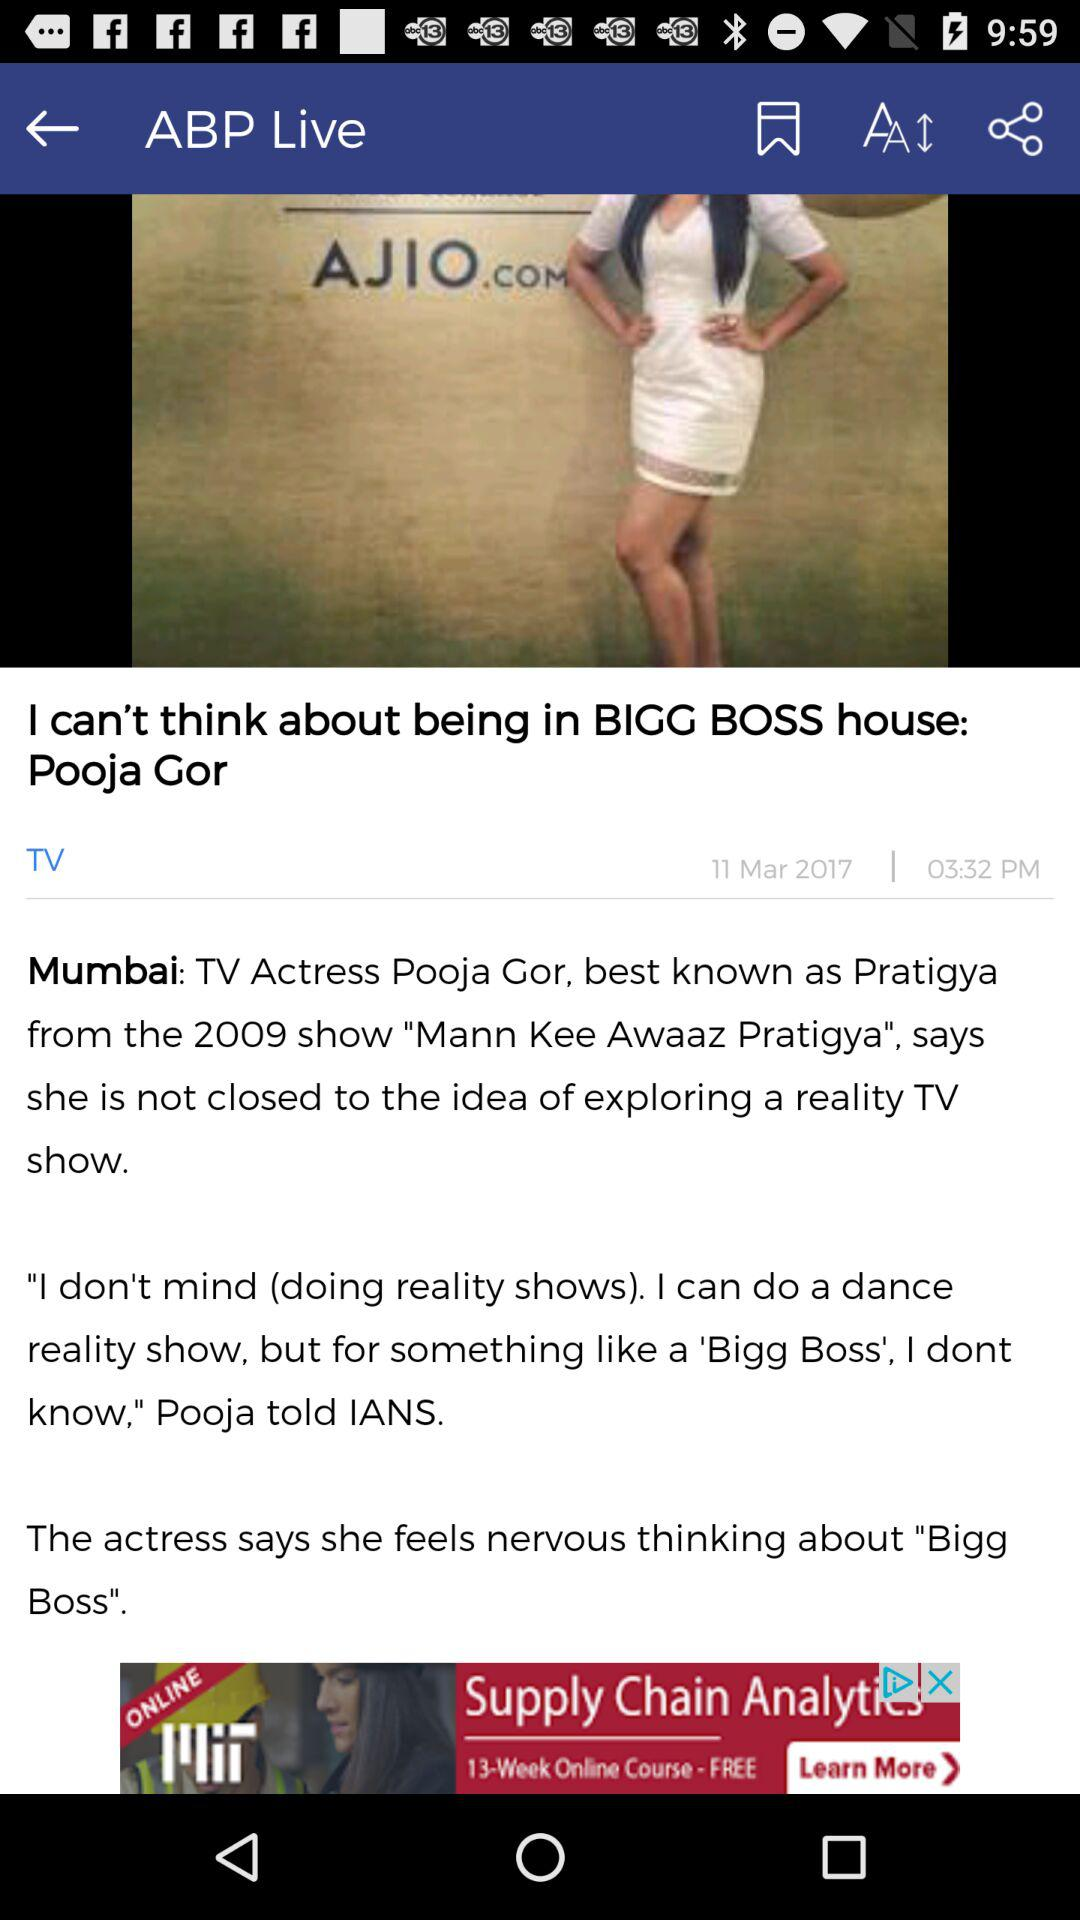When was this article published? This article was published on March 11, 2017 at 03:32 PM. 